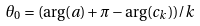<formula> <loc_0><loc_0><loc_500><loc_500>\theta _ { 0 } = ( \arg ( a ) + \pi - \arg ( c _ { k } ) ) / k</formula> 